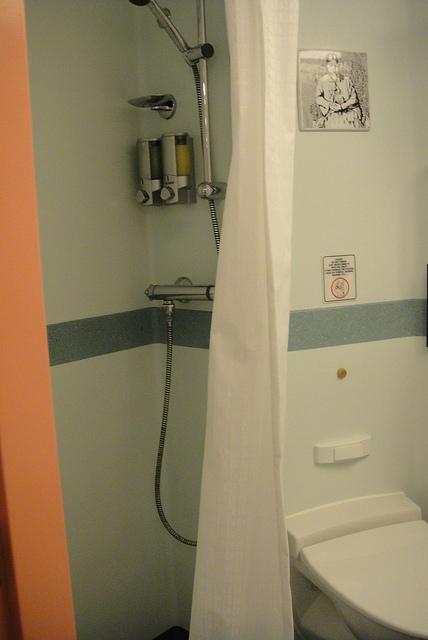Where is the picture?
Answer briefly. Bathroom. What room is this?
Answer briefly. Bathroom. Is the toilet lid open or closed?
Write a very short answer. Closed. 